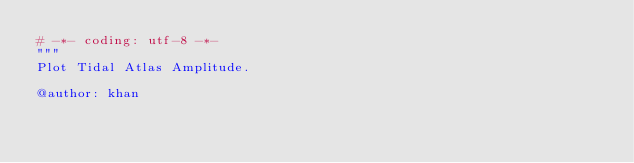Convert code to text. <code><loc_0><loc_0><loc_500><loc_500><_Python_># -*- coding: utf-8 -*-
"""
Plot Tidal Atlas Amplitude.

@author: khan</code> 